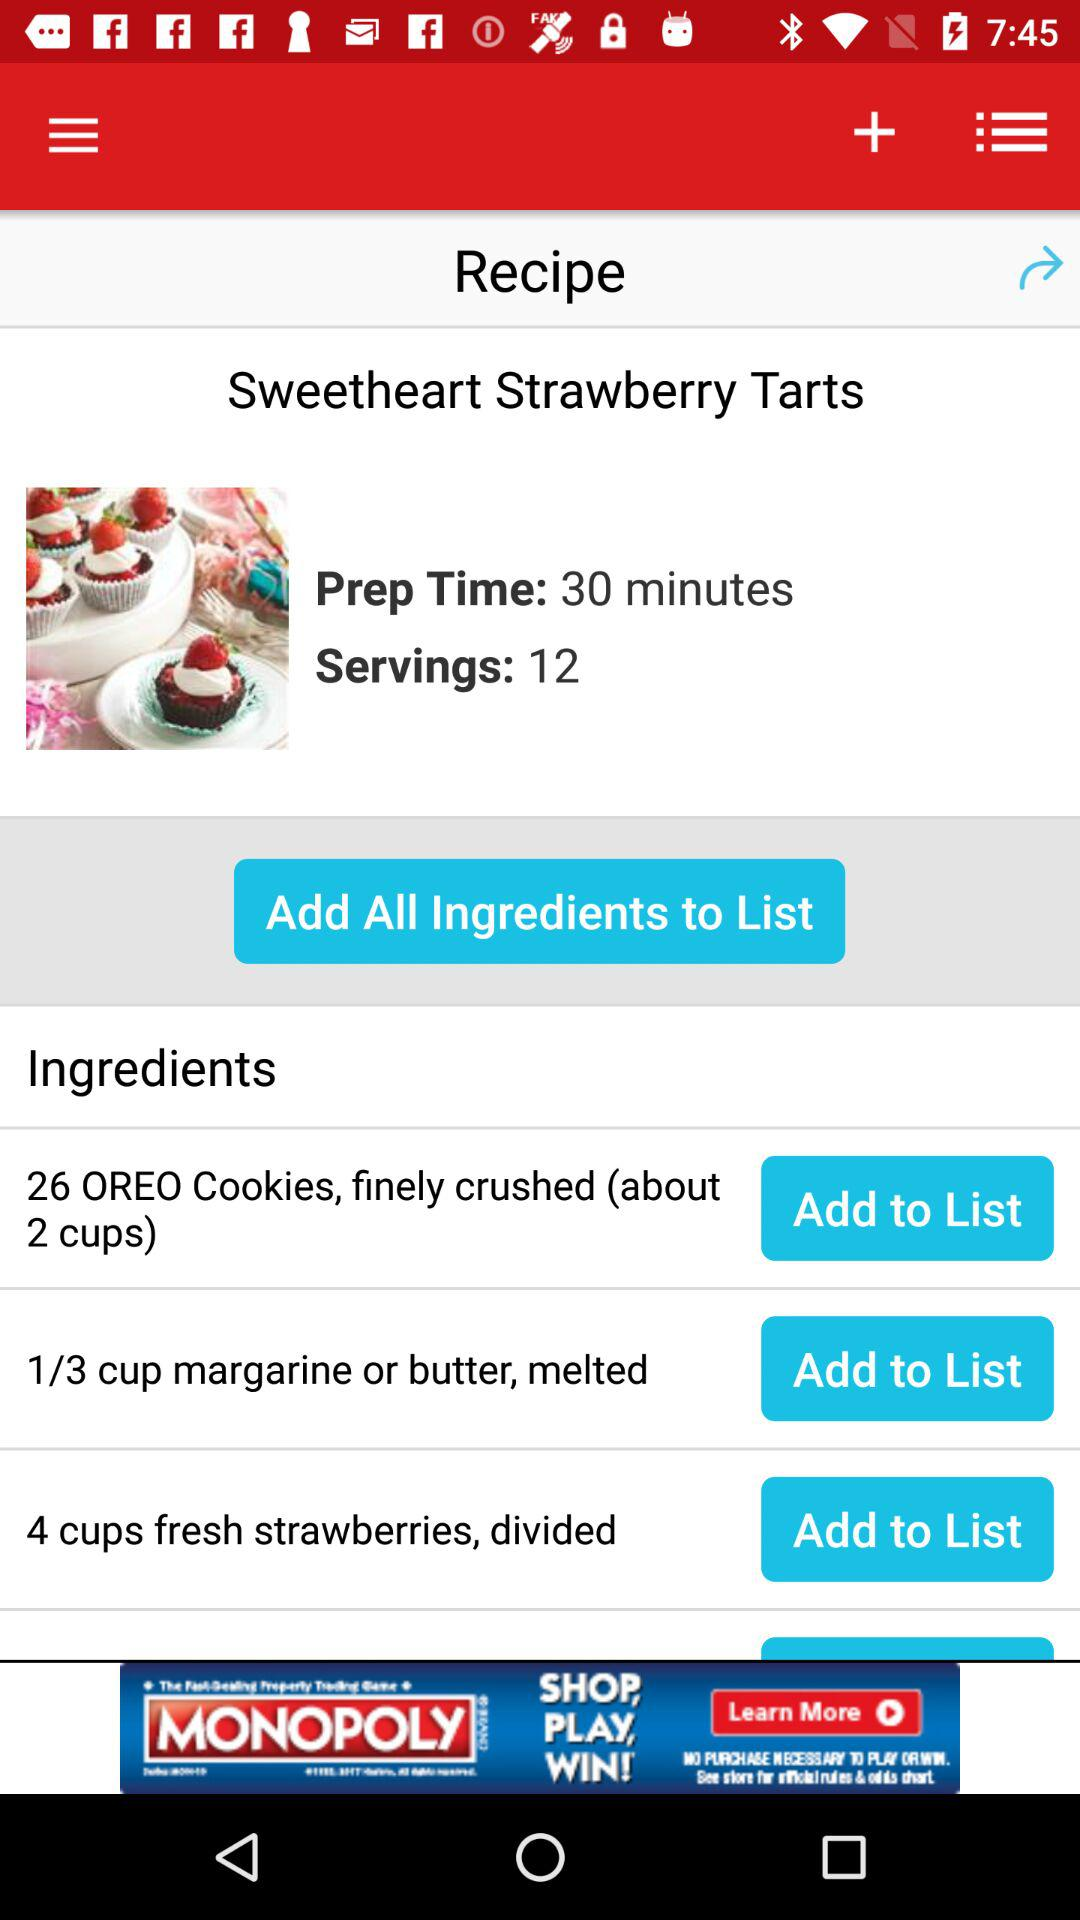How many servings are there? There are 12 servings. 